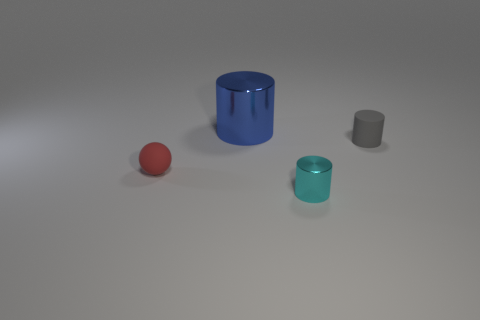Subtract all gray cylinders. How many cylinders are left? 2 Subtract all cyan cylinders. How many cylinders are left? 2 Add 1 tiny purple blocks. How many objects exist? 5 Subtract all spheres. How many objects are left? 3 Subtract all cyan metallic things. Subtract all red things. How many objects are left? 2 Add 2 big blue cylinders. How many big blue cylinders are left? 3 Add 1 tiny brown matte cylinders. How many tiny brown matte cylinders exist? 1 Subtract 0 yellow cubes. How many objects are left? 4 Subtract all purple spheres. Subtract all purple blocks. How many spheres are left? 1 Subtract all yellow cylinders. How many green spheres are left? 0 